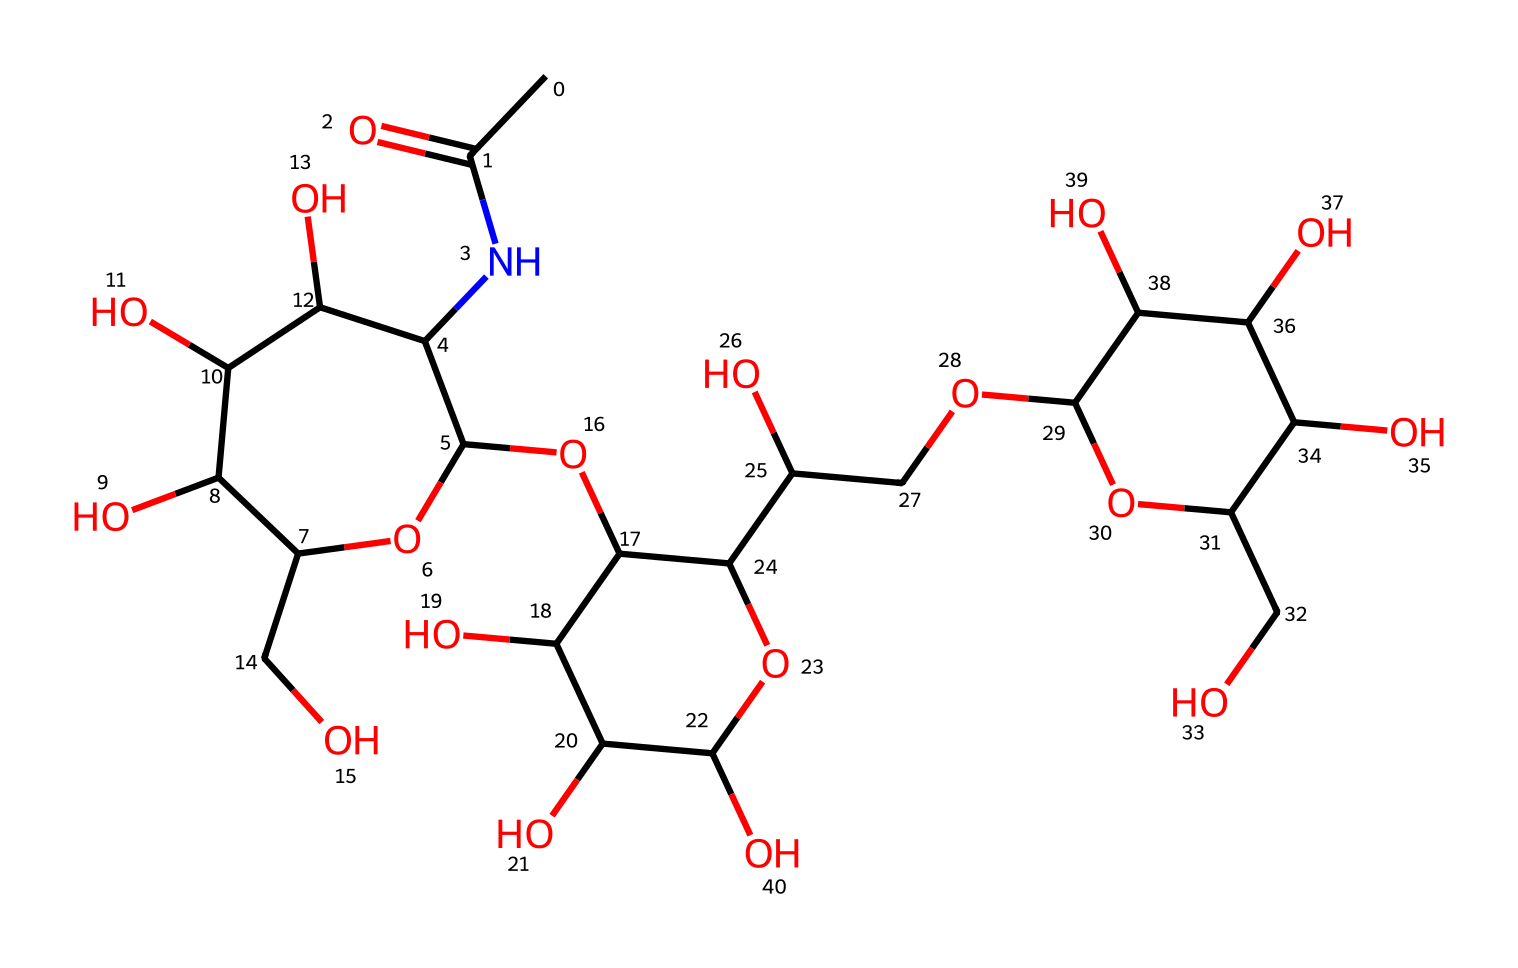What is the molecular formula of hyaluronic acid? To determine the molecular formula, count the number of carbon (C), hydrogen (H), nitrogen (N), and oxygen (O) atoms present in the structure. From analyzing the SMILES representation, we find that there are 21 carbon atoms, 37 hydrogen atoms, 1 nitrogen atom, and 12 oxygen atoms. Thus, the molecular formula is C21H37N1O12.
Answer: C21H37N1O12 How many rings are present in the hyaluronic acid structure? In the given SMILES representation, we look for the presence of cyclic structures indicated by the presence of numbers that denote the bond connections leading back to a previous atom. The structure contains two cycles denoted by the numbers 1 and 2, which means there are two rings in the molecule.
Answer: 2 What type of functional group is present due to the nitrogen atom? The presence of a nitrogen atom in the structure indicates the presence of an amide functional group, which is deduced from its connectivity with carbon and the carbonyl present (C=O) adjacent to it. This characteristic defines the molecule's behavior in biological systems and is indicative of protein-related structures.
Answer: amide Which part of this chemical provides its hydrophilic properties? The hydrophilic properties of hyaluronic acid can be attributed to the many hydroxyl (–OH) groups present throughout the molecule. These groups create an affinity for water, allowing the molecule to attract moisture, which is essential for its function in moisturizing cosmetics.
Answer: hydroxyl groups How many hydroxyl groups are present in the hyaluronic acid structure? To determine the number of hydroxyl (–OH) groups, carefully examine the structure for hydroxyl functionalities, which can be identified easily. In the structure's SMILES representation, counting each distinctly shows that there are 8 hydroxyl groups present.
Answer: 8 